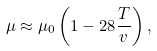<formula> <loc_0><loc_0><loc_500><loc_500>\mu \approx \mu _ { 0 } \left ( 1 - 2 8 \frac { T } { v } \right ) ,</formula> 